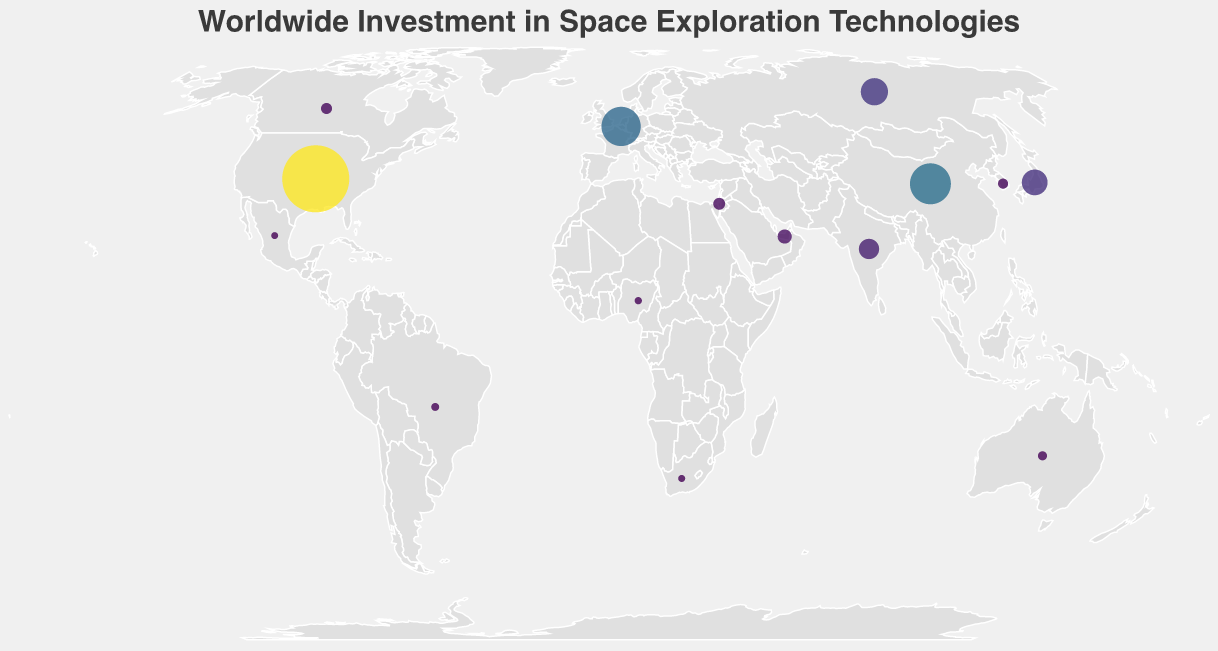What's the title of the figure? The title of a figure is usually displayed prominently at the top. The figure's title is "Worldwide Investment in Space Exploration Technologies."
Answer: Worldwide Investment in Space Exploration Technologies Which country has the highest investment in space exploration technologies? To determine the country with the highest investment, observe the size and color intensities of the circles. The United States has the largest and most intensely colored circle, indicating the highest investment of 22.9 billion USD.
Answer: United States How many countries are displayed on the map? Count the number of circles representing different countries. Each circle corresponds to one country, and there are 15 circles in total.
Answer: 15 What is the total investment of the top three investing entities (United States, China, European Union)? Sum the investments of the United States (22.9 billion USD), China (8.4 billion USD), and the European Union (7.7 billion USD): 22.9 + 8.4 + 7.7 = 39 billion USD.
Answer: 39 billion USD Which country has the smallest investment in space exploration technologies, and what is its value? Identify the country with the smallest circle size and the lightest color. Mexico has the smallest investment, valued at 0.02 billion USD.
Answer: Mexico, 0.02 billion USD What is the combined investment of the two countries with the smallest investments (Mexico and South Africa)? Sum the investments of Mexico (0.02 billion USD) and South Africa (0.03 billion USD): 0.02 + 0.03 = 0.05 billion USD.
Answer: 0.05 billion USD Which country in the Middle East has an investment in space exploration technologies, and what is its value? Locate the country in the Middle East. The United Arab Emirates has an investment, valued at 0.8 billion USD.
Answer: United Arab Emirates, 0.8 billion USD Which region (North America, Europe, Asia) has the highest combined investment? Sum investments per region. North America: United States (22.9) + Canada (0.4) + Mexico (0.02) = 23.32 billion USD. Europe: European Union (7.7) + Russia (3.6) + Israel (0.5) = 11.8 billion USD. Asia: China (8.4) + Japan (3.2) + India (1.9) + South Korea (0.3) = 13.8 billion USD. The region with the highest combined investment is North America with 23.32 billion USD.
Answer: North America 